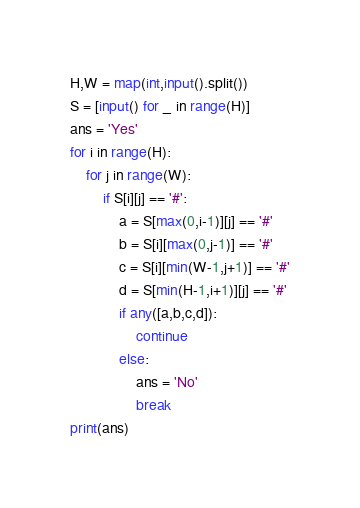<code> <loc_0><loc_0><loc_500><loc_500><_Python_>H,W = map(int,input().split())
S = [input() for _ in range(H)]
ans = 'Yes'
for i in range(H):
    for j in range(W):
        if S[i][j] == '#':
            a = S[max(0,i-1)][j] == '#'
            b = S[i][max(0,j-1)] == '#'
            c = S[i][min(W-1,j+1)] == '#'
            d = S[min(H-1,i+1)][j] == '#'
            if any([a,b,c,d]):
                continue
            else:
                ans = 'No'
                break
print(ans)</code> 